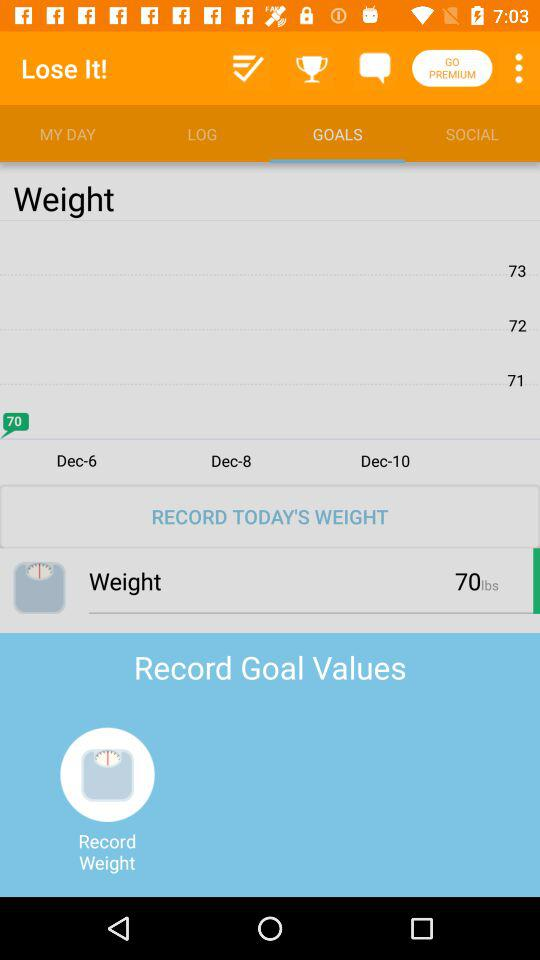What tab is selected? The selected tab is "GOALS". 